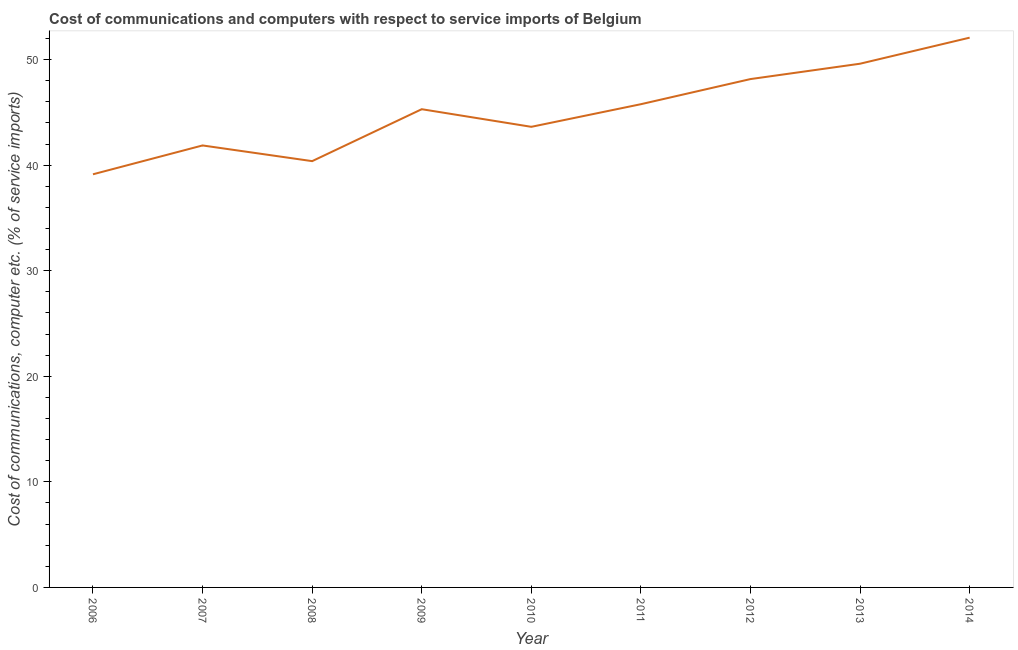What is the cost of communications and computer in 2010?
Your answer should be very brief. 43.63. Across all years, what is the maximum cost of communications and computer?
Make the answer very short. 52.08. Across all years, what is the minimum cost of communications and computer?
Your answer should be very brief. 39.14. In which year was the cost of communications and computer minimum?
Keep it short and to the point. 2006. What is the sum of the cost of communications and computer?
Offer a terse response. 405.94. What is the difference between the cost of communications and computer in 2007 and 2013?
Your response must be concise. -7.74. What is the average cost of communications and computer per year?
Provide a short and direct response. 45.1. What is the median cost of communications and computer?
Give a very brief answer. 45.3. In how many years, is the cost of communications and computer greater than 40 %?
Make the answer very short. 8. Do a majority of the years between 2011 and 2012 (inclusive) have cost of communications and computer greater than 50 %?
Offer a terse response. No. What is the ratio of the cost of communications and computer in 2009 to that in 2014?
Your answer should be very brief. 0.87. What is the difference between the highest and the second highest cost of communications and computer?
Your answer should be very brief. 2.47. Is the sum of the cost of communications and computer in 2006 and 2008 greater than the maximum cost of communications and computer across all years?
Give a very brief answer. Yes. What is the difference between the highest and the lowest cost of communications and computer?
Your answer should be very brief. 12.94. Does the cost of communications and computer monotonically increase over the years?
Offer a very short reply. No. How many years are there in the graph?
Give a very brief answer. 9. Are the values on the major ticks of Y-axis written in scientific E-notation?
Provide a short and direct response. No. Does the graph contain any zero values?
Offer a very short reply. No. Does the graph contain grids?
Offer a terse response. No. What is the title of the graph?
Offer a terse response. Cost of communications and computers with respect to service imports of Belgium. What is the label or title of the Y-axis?
Offer a terse response. Cost of communications, computer etc. (% of service imports). What is the Cost of communications, computer etc. (% of service imports) of 2006?
Offer a very short reply. 39.14. What is the Cost of communications, computer etc. (% of service imports) in 2007?
Give a very brief answer. 41.87. What is the Cost of communications, computer etc. (% of service imports) of 2008?
Provide a succinct answer. 40.38. What is the Cost of communications, computer etc. (% of service imports) of 2009?
Your answer should be very brief. 45.3. What is the Cost of communications, computer etc. (% of service imports) in 2010?
Provide a succinct answer. 43.63. What is the Cost of communications, computer etc. (% of service imports) in 2011?
Your answer should be very brief. 45.78. What is the Cost of communications, computer etc. (% of service imports) in 2012?
Ensure brevity in your answer.  48.16. What is the Cost of communications, computer etc. (% of service imports) of 2013?
Your answer should be very brief. 49.61. What is the Cost of communications, computer etc. (% of service imports) of 2014?
Ensure brevity in your answer.  52.08. What is the difference between the Cost of communications, computer etc. (% of service imports) in 2006 and 2007?
Provide a succinct answer. -2.73. What is the difference between the Cost of communications, computer etc. (% of service imports) in 2006 and 2008?
Ensure brevity in your answer.  -1.25. What is the difference between the Cost of communications, computer etc. (% of service imports) in 2006 and 2009?
Keep it short and to the point. -6.17. What is the difference between the Cost of communications, computer etc. (% of service imports) in 2006 and 2010?
Provide a succinct answer. -4.5. What is the difference between the Cost of communications, computer etc. (% of service imports) in 2006 and 2011?
Your answer should be very brief. -6.64. What is the difference between the Cost of communications, computer etc. (% of service imports) in 2006 and 2012?
Offer a very short reply. -9.02. What is the difference between the Cost of communications, computer etc. (% of service imports) in 2006 and 2013?
Provide a short and direct response. -10.48. What is the difference between the Cost of communications, computer etc. (% of service imports) in 2006 and 2014?
Your answer should be very brief. -12.94. What is the difference between the Cost of communications, computer etc. (% of service imports) in 2007 and 2008?
Ensure brevity in your answer.  1.49. What is the difference between the Cost of communications, computer etc. (% of service imports) in 2007 and 2009?
Your answer should be very brief. -3.43. What is the difference between the Cost of communications, computer etc. (% of service imports) in 2007 and 2010?
Ensure brevity in your answer.  -1.76. What is the difference between the Cost of communications, computer etc. (% of service imports) in 2007 and 2011?
Keep it short and to the point. -3.91. What is the difference between the Cost of communications, computer etc. (% of service imports) in 2007 and 2012?
Ensure brevity in your answer.  -6.29. What is the difference between the Cost of communications, computer etc. (% of service imports) in 2007 and 2013?
Your response must be concise. -7.74. What is the difference between the Cost of communications, computer etc. (% of service imports) in 2007 and 2014?
Your answer should be compact. -10.21. What is the difference between the Cost of communications, computer etc. (% of service imports) in 2008 and 2009?
Your answer should be very brief. -4.92. What is the difference between the Cost of communications, computer etc. (% of service imports) in 2008 and 2010?
Give a very brief answer. -3.25. What is the difference between the Cost of communications, computer etc. (% of service imports) in 2008 and 2011?
Your answer should be compact. -5.39. What is the difference between the Cost of communications, computer etc. (% of service imports) in 2008 and 2012?
Make the answer very short. -7.77. What is the difference between the Cost of communications, computer etc. (% of service imports) in 2008 and 2013?
Offer a terse response. -9.23. What is the difference between the Cost of communications, computer etc. (% of service imports) in 2008 and 2014?
Offer a terse response. -11.7. What is the difference between the Cost of communications, computer etc. (% of service imports) in 2009 and 2010?
Provide a succinct answer. 1.67. What is the difference between the Cost of communications, computer etc. (% of service imports) in 2009 and 2011?
Give a very brief answer. -0.47. What is the difference between the Cost of communications, computer etc. (% of service imports) in 2009 and 2012?
Offer a terse response. -2.85. What is the difference between the Cost of communications, computer etc. (% of service imports) in 2009 and 2013?
Your answer should be very brief. -4.31. What is the difference between the Cost of communications, computer etc. (% of service imports) in 2009 and 2014?
Your response must be concise. -6.78. What is the difference between the Cost of communications, computer etc. (% of service imports) in 2010 and 2011?
Your answer should be compact. -2.14. What is the difference between the Cost of communications, computer etc. (% of service imports) in 2010 and 2012?
Make the answer very short. -4.52. What is the difference between the Cost of communications, computer etc. (% of service imports) in 2010 and 2013?
Provide a short and direct response. -5.98. What is the difference between the Cost of communications, computer etc. (% of service imports) in 2010 and 2014?
Make the answer very short. -8.45. What is the difference between the Cost of communications, computer etc. (% of service imports) in 2011 and 2012?
Give a very brief answer. -2.38. What is the difference between the Cost of communications, computer etc. (% of service imports) in 2011 and 2013?
Keep it short and to the point. -3.84. What is the difference between the Cost of communications, computer etc. (% of service imports) in 2011 and 2014?
Make the answer very short. -6.3. What is the difference between the Cost of communications, computer etc. (% of service imports) in 2012 and 2013?
Ensure brevity in your answer.  -1.46. What is the difference between the Cost of communications, computer etc. (% of service imports) in 2012 and 2014?
Your answer should be compact. -3.92. What is the difference between the Cost of communications, computer etc. (% of service imports) in 2013 and 2014?
Make the answer very short. -2.47. What is the ratio of the Cost of communications, computer etc. (% of service imports) in 2006 to that in 2007?
Offer a very short reply. 0.94. What is the ratio of the Cost of communications, computer etc. (% of service imports) in 2006 to that in 2008?
Ensure brevity in your answer.  0.97. What is the ratio of the Cost of communications, computer etc. (% of service imports) in 2006 to that in 2009?
Provide a short and direct response. 0.86. What is the ratio of the Cost of communications, computer etc. (% of service imports) in 2006 to that in 2010?
Give a very brief answer. 0.9. What is the ratio of the Cost of communications, computer etc. (% of service imports) in 2006 to that in 2011?
Ensure brevity in your answer.  0.85. What is the ratio of the Cost of communications, computer etc. (% of service imports) in 2006 to that in 2012?
Provide a succinct answer. 0.81. What is the ratio of the Cost of communications, computer etc. (% of service imports) in 2006 to that in 2013?
Keep it short and to the point. 0.79. What is the ratio of the Cost of communications, computer etc. (% of service imports) in 2006 to that in 2014?
Offer a terse response. 0.75. What is the ratio of the Cost of communications, computer etc. (% of service imports) in 2007 to that in 2008?
Keep it short and to the point. 1.04. What is the ratio of the Cost of communications, computer etc. (% of service imports) in 2007 to that in 2009?
Provide a succinct answer. 0.92. What is the ratio of the Cost of communications, computer etc. (% of service imports) in 2007 to that in 2010?
Make the answer very short. 0.96. What is the ratio of the Cost of communications, computer etc. (% of service imports) in 2007 to that in 2011?
Provide a short and direct response. 0.92. What is the ratio of the Cost of communications, computer etc. (% of service imports) in 2007 to that in 2012?
Make the answer very short. 0.87. What is the ratio of the Cost of communications, computer etc. (% of service imports) in 2007 to that in 2013?
Offer a terse response. 0.84. What is the ratio of the Cost of communications, computer etc. (% of service imports) in 2007 to that in 2014?
Give a very brief answer. 0.8. What is the ratio of the Cost of communications, computer etc. (% of service imports) in 2008 to that in 2009?
Ensure brevity in your answer.  0.89. What is the ratio of the Cost of communications, computer etc. (% of service imports) in 2008 to that in 2010?
Make the answer very short. 0.93. What is the ratio of the Cost of communications, computer etc. (% of service imports) in 2008 to that in 2011?
Make the answer very short. 0.88. What is the ratio of the Cost of communications, computer etc. (% of service imports) in 2008 to that in 2012?
Make the answer very short. 0.84. What is the ratio of the Cost of communications, computer etc. (% of service imports) in 2008 to that in 2013?
Your answer should be compact. 0.81. What is the ratio of the Cost of communications, computer etc. (% of service imports) in 2008 to that in 2014?
Offer a very short reply. 0.78. What is the ratio of the Cost of communications, computer etc. (% of service imports) in 2009 to that in 2010?
Give a very brief answer. 1.04. What is the ratio of the Cost of communications, computer etc. (% of service imports) in 2009 to that in 2011?
Your answer should be compact. 0.99. What is the ratio of the Cost of communications, computer etc. (% of service imports) in 2009 to that in 2012?
Ensure brevity in your answer.  0.94. What is the ratio of the Cost of communications, computer etc. (% of service imports) in 2009 to that in 2014?
Your answer should be very brief. 0.87. What is the ratio of the Cost of communications, computer etc. (% of service imports) in 2010 to that in 2011?
Offer a terse response. 0.95. What is the ratio of the Cost of communications, computer etc. (% of service imports) in 2010 to that in 2012?
Provide a succinct answer. 0.91. What is the ratio of the Cost of communications, computer etc. (% of service imports) in 2010 to that in 2013?
Your answer should be compact. 0.88. What is the ratio of the Cost of communications, computer etc. (% of service imports) in 2010 to that in 2014?
Keep it short and to the point. 0.84. What is the ratio of the Cost of communications, computer etc. (% of service imports) in 2011 to that in 2012?
Your answer should be compact. 0.95. What is the ratio of the Cost of communications, computer etc. (% of service imports) in 2011 to that in 2013?
Offer a very short reply. 0.92. What is the ratio of the Cost of communications, computer etc. (% of service imports) in 2011 to that in 2014?
Offer a terse response. 0.88. What is the ratio of the Cost of communications, computer etc. (% of service imports) in 2012 to that in 2013?
Make the answer very short. 0.97. What is the ratio of the Cost of communications, computer etc. (% of service imports) in 2012 to that in 2014?
Make the answer very short. 0.93. What is the ratio of the Cost of communications, computer etc. (% of service imports) in 2013 to that in 2014?
Your response must be concise. 0.95. 